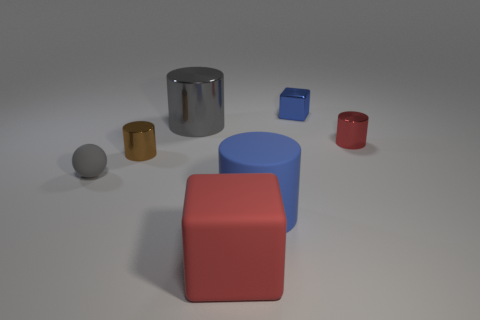Add 2 big red objects. How many objects exist? 9 Subtract all blocks. How many objects are left? 5 Add 3 small blue objects. How many small blue objects exist? 4 Subtract 0 yellow spheres. How many objects are left? 7 Subtract all purple metal blocks. Subtract all tiny brown metallic objects. How many objects are left? 6 Add 3 blue cubes. How many blue cubes are left? 4 